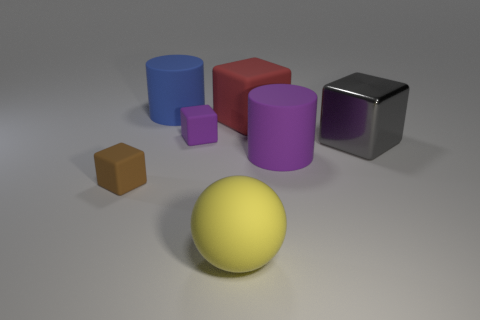Subtract all tiny brown matte blocks. How many blocks are left? 3 Add 2 purple rubber cylinders. How many objects exist? 9 Subtract all gray blocks. How many blocks are left? 3 Subtract all blocks. How many objects are left? 3 Subtract 1 cubes. How many cubes are left? 3 Subtract all yellow blocks. Subtract all cyan cylinders. How many blocks are left? 4 Subtract all red objects. Subtract all large cubes. How many objects are left? 4 Add 3 blue matte objects. How many blue matte objects are left? 4 Add 7 blue matte things. How many blue matte things exist? 8 Subtract 1 blue cylinders. How many objects are left? 6 